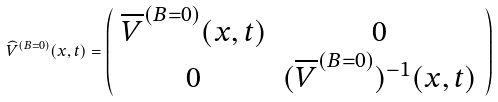<formula> <loc_0><loc_0><loc_500><loc_500>\widehat { V } ^ { ( B = 0 ) } ( x , t ) = \left ( \begin{array} { c c } \overline { V } ^ { ( B = 0 ) } ( x , t ) & 0 \\ 0 & ( \overline { V } ^ { ( B = 0 ) } ) ^ { - 1 } ( x , t ) \end{array} \right )</formula> 